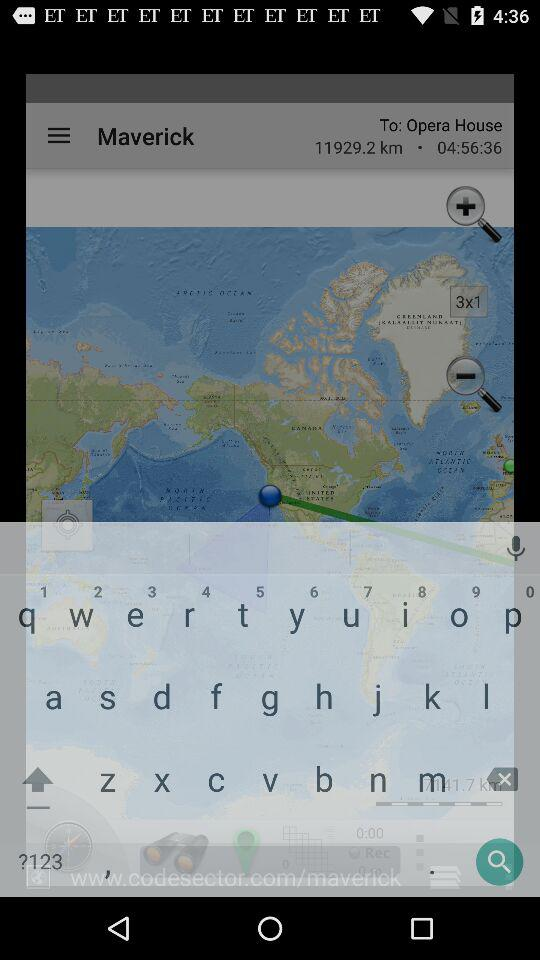What is the given distance? The given distance is 11929.2 km. 